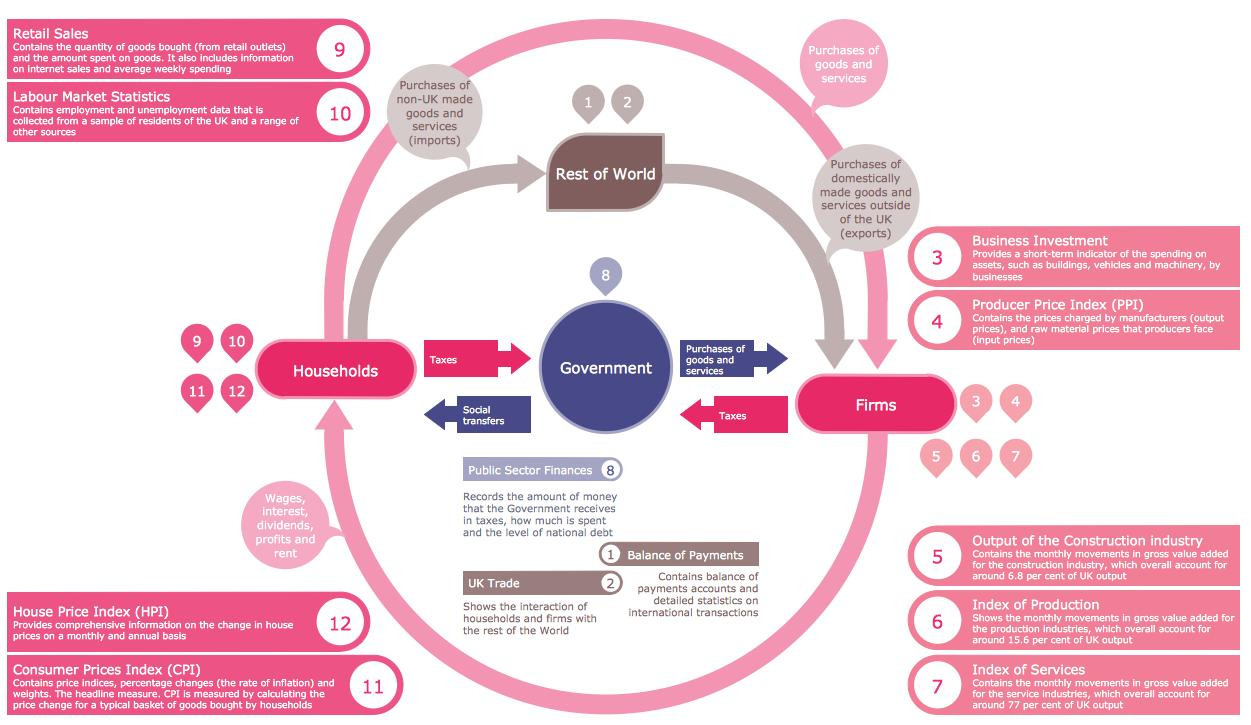Highlight a few significant elements in this photo. Taxes are paid to the government. The light pink arrow indicates the relationship between households and firms. Social transfers, such as welfare or unemployment benefits, primarily go to households. 